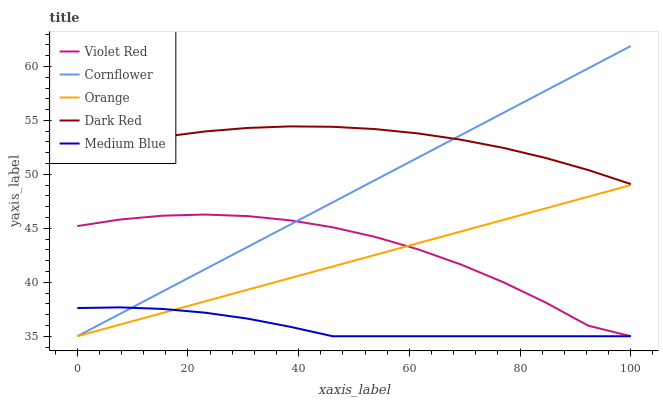Does Medium Blue have the minimum area under the curve?
Answer yes or no. Yes. Does Dark Red have the maximum area under the curve?
Answer yes or no. Yes. Does Cornflower have the minimum area under the curve?
Answer yes or no. No. Does Cornflower have the maximum area under the curve?
Answer yes or no. No. Is Orange the smoothest?
Answer yes or no. Yes. Is Violet Red the roughest?
Answer yes or no. Yes. Is Cornflower the smoothest?
Answer yes or no. No. Is Cornflower the roughest?
Answer yes or no. No. Does Orange have the lowest value?
Answer yes or no. Yes. Does Dark Red have the lowest value?
Answer yes or no. No. Does Cornflower have the highest value?
Answer yes or no. Yes. Does Violet Red have the highest value?
Answer yes or no. No. Is Violet Red less than Dark Red?
Answer yes or no. Yes. Is Dark Red greater than Medium Blue?
Answer yes or no. Yes. Does Violet Red intersect Orange?
Answer yes or no. Yes. Is Violet Red less than Orange?
Answer yes or no. No. Is Violet Red greater than Orange?
Answer yes or no. No. Does Violet Red intersect Dark Red?
Answer yes or no. No. 